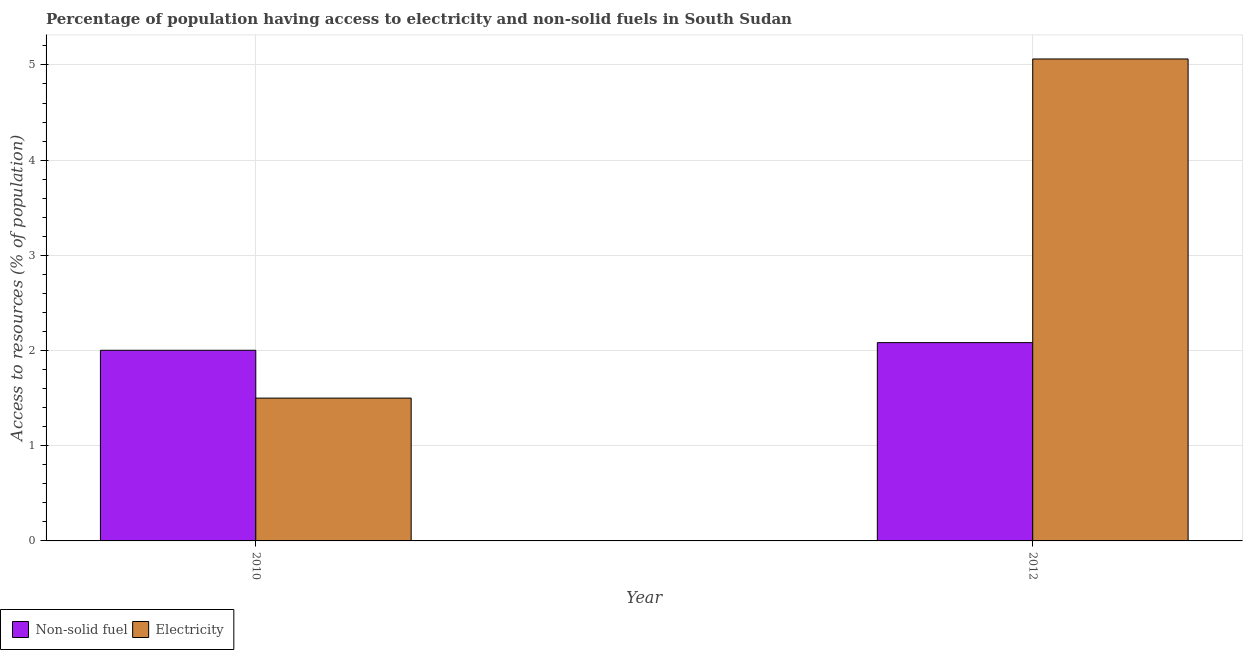How many different coloured bars are there?
Offer a terse response. 2. Are the number of bars on each tick of the X-axis equal?
Provide a succinct answer. Yes. What is the label of the 2nd group of bars from the left?
Give a very brief answer. 2012. In how many cases, is the number of bars for a given year not equal to the number of legend labels?
Make the answer very short. 0. What is the percentage of population having access to non-solid fuel in 2012?
Offer a terse response. 2.08. Across all years, what is the maximum percentage of population having access to non-solid fuel?
Ensure brevity in your answer.  2.08. Across all years, what is the minimum percentage of population having access to electricity?
Make the answer very short. 1.5. In which year was the percentage of population having access to non-solid fuel maximum?
Keep it short and to the point. 2012. What is the total percentage of population having access to electricity in the graph?
Provide a short and direct response. 6.56. What is the difference between the percentage of population having access to non-solid fuel in 2010 and that in 2012?
Provide a short and direct response. -0.08. What is the difference between the percentage of population having access to non-solid fuel in 2012 and the percentage of population having access to electricity in 2010?
Provide a short and direct response. 0.08. What is the average percentage of population having access to non-solid fuel per year?
Make the answer very short. 2.04. In how many years, is the percentage of population having access to non-solid fuel greater than 1.4 %?
Give a very brief answer. 2. What is the ratio of the percentage of population having access to electricity in 2010 to that in 2012?
Offer a terse response. 0.3. In how many years, is the percentage of population having access to non-solid fuel greater than the average percentage of population having access to non-solid fuel taken over all years?
Offer a terse response. 1. What does the 1st bar from the left in 2012 represents?
Offer a terse response. Non-solid fuel. What does the 1st bar from the right in 2012 represents?
Offer a terse response. Electricity. Are the values on the major ticks of Y-axis written in scientific E-notation?
Your answer should be compact. No. Does the graph contain any zero values?
Give a very brief answer. No. How many legend labels are there?
Offer a terse response. 2. How are the legend labels stacked?
Keep it short and to the point. Horizontal. What is the title of the graph?
Offer a terse response. Percentage of population having access to electricity and non-solid fuels in South Sudan. Does "Taxes on exports" appear as one of the legend labels in the graph?
Your answer should be very brief. No. What is the label or title of the Y-axis?
Provide a succinct answer. Access to resources (% of population). What is the Access to resources (% of population) of Non-solid fuel in 2010?
Give a very brief answer. 2. What is the Access to resources (% of population) of Electricity in 2010?
Your answer should be compact. 1.5. What is the Access to resources (% of population) of Non-solid fuel in 2012?
Your answer should be compact. 2.08. What is the Access to resources (% of population) of Electricity in 2012?
Offer a very short reply. 5.06. Across all years, what is the maximum Access to resources (% of population) of Non-solid fuel?
Your response must be concise. 2.08. Across all years, what is the maximum Access to resources (% of population) of Electricity?
Give a very brief answer. 5.06. Across all years, what is the minimum Access to resources (% of population) in Non-solid fuel?
Your answer should be compact. 2. What is the total Access to resources (% of population) of Non-solid fuel in the graph?
Your answer should be compact. 4.09. What is the total Access to resources (% of population) in Electricity in the graph?
Ensure brevity in your answer.  6.56. What is the difference between the Access to resources (% of population) of Non-solid fuel in 2010 and that in 2012?
Ensure brevity in your answer.  -0.08. What is the difference between the Access to resources (% of population) of Electricity in 2010 and that in 2012?
Your response must be concise. -3.56. What is the difference between the Access to resources (% of population) of Non-solid fuel in 2010 and the Access to resources (% of population) of Electricity in 2012?
Offer a terse response. -3.06. What is the average Access to resources (% of population) of Non-solid fuel per year?
Give a very brief answer. 2.04. What is the average Access to resources (% of population) in Electricity per year?
Provide a succinct answer. 3.28. In the year 2010, what is the difference between the Access to resources (% of population) of Non-solid fuel and Access to resources (% of population) of Electricity?
Provide a succinct answer. 0.5. In the year 2012, what is the difference between the Access to resources (% of population) of Non-solid fuel and Access to resources (% of population) of Electricity?
Provide a short and direct response. -2.98. What is the ratio of the Access to resources (% of population) in Non-solid fuel in 2010 to that in 2012?
Your answer should be very brief. 0.96. What is the ratio of the Access to resources (% of population) in Electricity in 2010 to that in 2012?
Offer a very short reply. 0.3. What is the difference between the highest and the second highest Access to resources (% of population) in Non-solid fuel?
Keep it short and to the point. 0.08. What is the difference between the highest and the second highest Access to resources (% of population) in Electricity?
Ensure brevity in your answer.  3.56. What is the difference between the highest and the lowest Access to resources (% of population) of Non-solid fuel?
Your answer should be very brief. 0.08. What is the difference between the highest and the lowest Access to resources (% of population) in Electricity?
Your response must be concise. 3.56. 